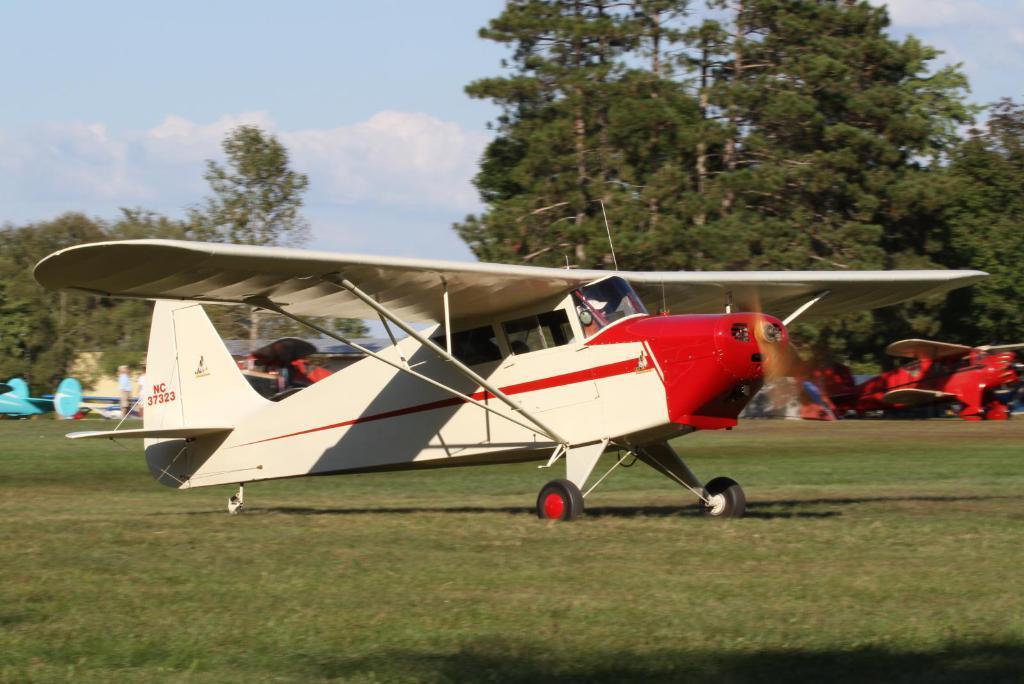Could you give a brief overview of what you see in this image? In this picture we can see aircraft on the grass, two people, trees and in the background we can see the sky with clouds. 